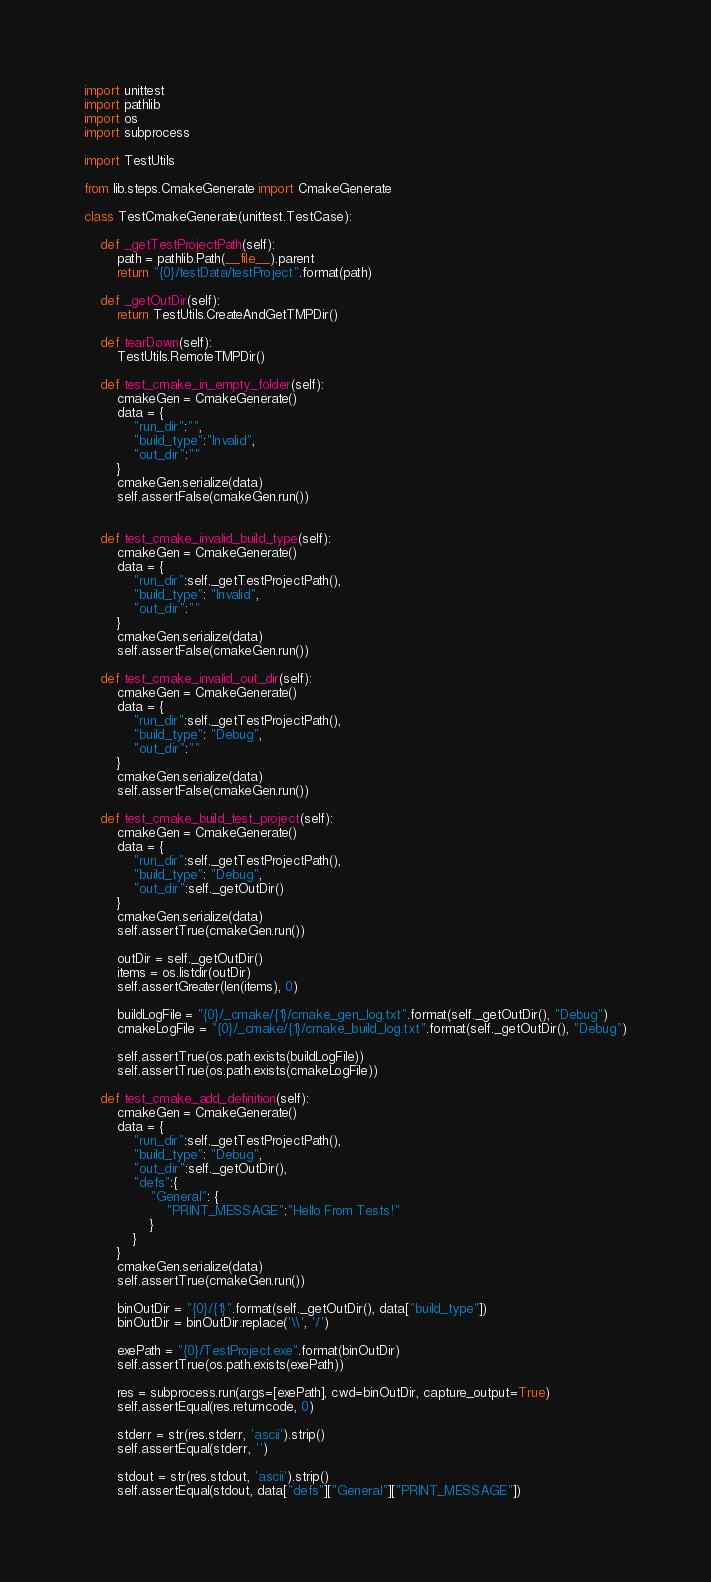<code> <loc_0><loc_0><loc_500><loc_500><_Python_>import unittest
import pathlib
import os
import subprocess

import TestUtils

from lib.steps.CmakeGenerate import CmakeGenerate

class TestCmakeGenerate(unittest.TestCase):

    def _getTestProjectPath(self):
        path = pathlib.Path(__file__).parent
        return "{0}/testData/testProject".format(path)

    def _getOutDir(self):
        return TestUtils.CreateAndGetTMPDir()

    def tearDown(self):
        TestUtils.RemoteTMPDir()

    def test_cmake_in_empty_folder(self):
        cmakeGen = CmakeGenerate()
        data = {
            "run_dir":"",
            "build_type":"Invalid",
            "out_dir":""
        }
        cmakeGen.serialize(data)
        self.assertFalse(cmakeGen.run())


    def test_cmake_invalid_build_type(self):
        cmakeGen = CmakeGenerate()
        data = {
            "run_dir":self._getTestProjectPath(),
            "build_type": "Invalid",
            "out_dir":""
        }
        cmakeGen.serialize(data)
        self.assertFalse(cmakeGen.run())

    def test_cmake_invalid_out_dir(self):
        cmakeGen = CmakeGenerate()
        data = {
            "run_dir":self._getTestProjectPath(),
            "build_type": "Debug",
            "out_dir":""
        }
        cmakeGen.serialize(data)
        self.assertFalse(cmakeGen.run())

    def test_cmake_build_test_project(self):
        cmakeGen = CmakeGenerate()
        data = {
            "run_dir":self._getTestProjectPath(),
            "build_type": "Debug",
            "out_dir":self._getOutDir()
        }
        cmakeGen.serialize(data)
        self.assertTrue(cmakeGen.run())

        outDir = self._getOutDir()
        items = os.listdir(outDir)
        self.assertGreater(len(items), 0)

        buildLogFile = "{0}/_cmake/{1}/cmake_gen_log.txt".format(self._getOutDir(), "Debug")
        cmakeLogFile = "{0}/_cmake/{1}/cmake_build_log.txt".format(self._getOutDir(), "Debug")

        self.assertTrue(os.path.exists(buildLogFile))
        self.assertTrue(os.path.exists(cmakeLogFile))

    def test_cmake_add_definition(self):
        cmakeGen = CmakeGenerate()
        data = {
            "run_dir":self._getTestProjectPath(),
            "build_type": "Debug",
            "out_dir":self._getOutDir(),
            "defs":{
                "General": {
                    "PRINT_MESSAGE":"Hello From Tests!"
                }
            }
        }
        cmakeGen.serialize(data)
        self.assertTrue(cmakeGen.run())

        binOutDir = "{0}/{1}".format(self._getOutDir(), data["build_type"])
        binOutDir = binOutDir.replace('\\', '/')

        exePath = "{0}/TestProject.exe".format(binOutDir)
        self.assertTrue(os.path.exists(exePath))

        res = subprocess.run(args=[exePath], cwd=binOutDir, capture_output=True)
        self.assertEqual(res.returncode, 0)

        stderr = str(res.stderr, 'ascii').strip()
        self.assertEqual(stderr, '')

        stdout = str(res.stdout, 'ascii').strip()
        self.assertEqual(stdout, data["defs"]["General"]["PRINT_MESSAGE"])</code> 